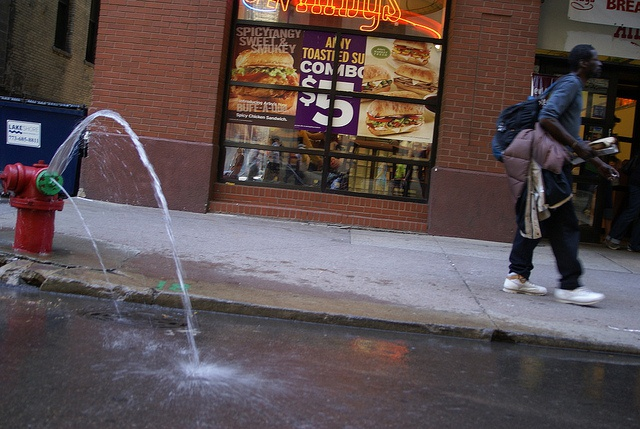Describe the objects in this image and their specific colors. I can see people in black, gray, navy, and darkgray tones, fire hydrant in black, maroon, gray, and darkgreen tones, and backpack in black, navy, darkblue, and gray tones in this image. 